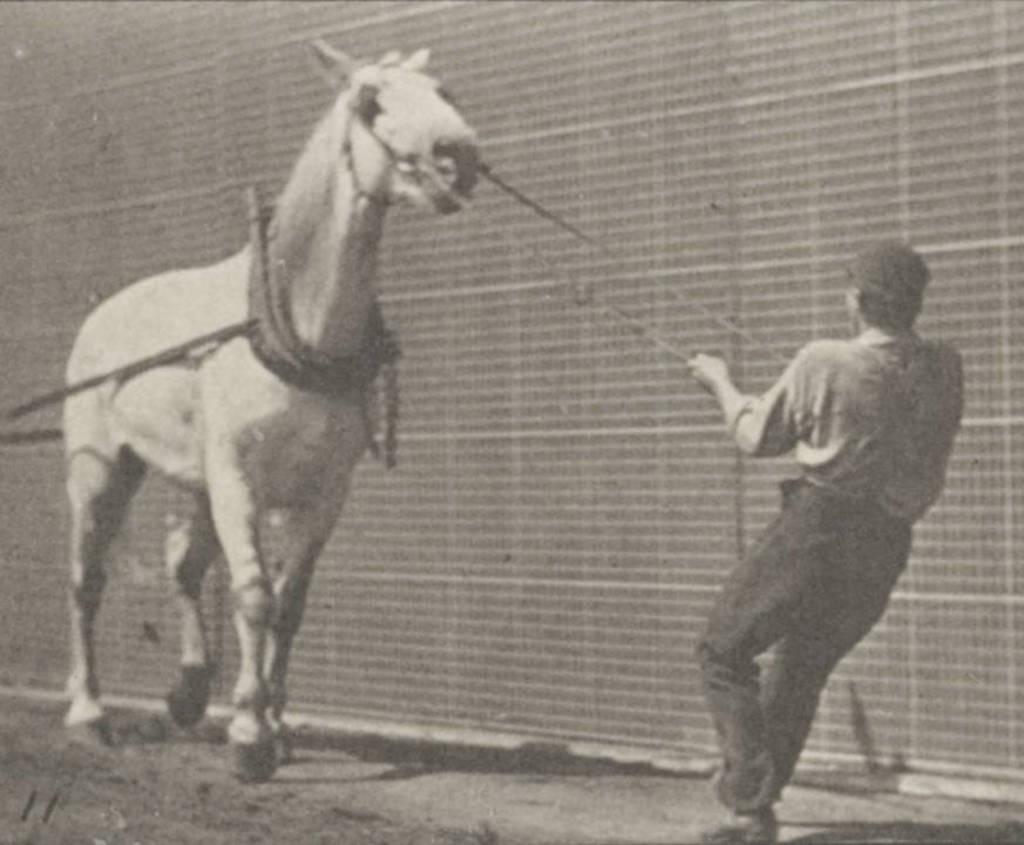Describe this image in one or two sentences. This looks like an old black and white image. I can see a horse and a man standing. This man is holding the ropes and pulling the horse. I think this is the wall. 